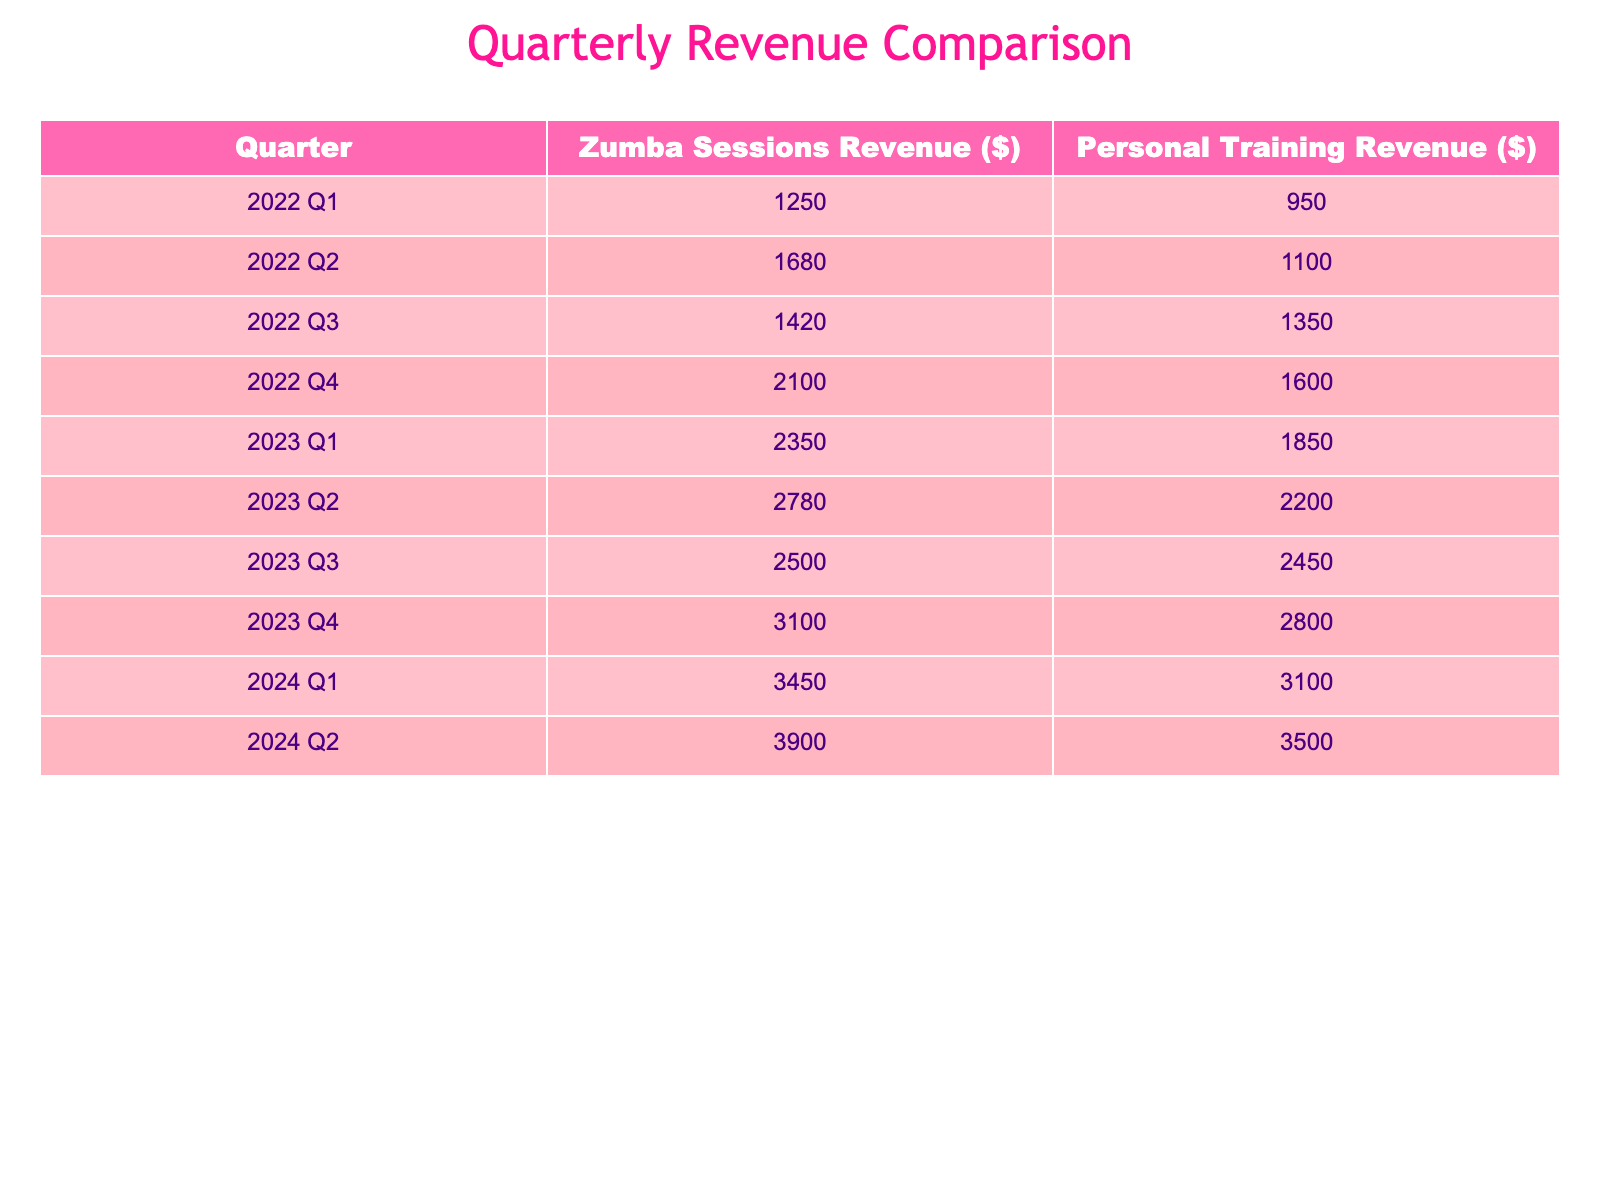What was the revenue from Zumba sessions in 2023 Q2? The table shows that in 2023 Q2, the revenue from Zumba sessions is listed as $2780.
Answer: $2780 What is the total revenue from personal training over all quarters in 2022? By summing the personal training revenue for each quarter in 2022, we get: 950 + 1100 + 1350 + 1600 = 4000.
Answer: $4000 Was the Zumba revenue in 2024 Q1 higher than in 2022 Q4? In 2024 Q1, the Zumba revenue was $3450, and in 2022 Q4, it was $2100. Since $3450 is greater than $2100, the statement is true.
Answer: Yes Calculate the average Zumba revenue for the first two quarters of 2023. For the first two quarters of 2023, the revenues are: 2350 (Q1) and 2780 (Q2). The sum is 2350 + 2780 = 5130. The average is then 5130 / 2 = 2565.
Answer: $2565 Which quarter had the highest revenue from personal training in 2023? Looking at the personal training revenue in 2023, the values are: 1850 (Q1), 2200 (Q2), 2450 (Q3), and 2800 (Q4). The highest is 2800 in Q4.
Answer: 2023 Q4 By how much did the Zumba revenue increase from 2022 Q1 to 2024 Q2? The Zumba revenue in 2022 Q1 is $1250 and in 2024 Q2 it is $3900. To find the increase, calculate: 3900 - 1250 = 2650.
Answer: $2650 What was the personal training revenue in Q3 2022 in comparison to Q3 2023? In Q3 2022, the personal training revenue was $1350, while in Q3 2023, it was $2450. Since $2450 is higher than $1350, the revenue increased.
Answer: Increased Find the total revenue from Zumba sessions for the first half of 2024. The revenues for Zumba in the first half of 2024 are: 3450 (Q1) and 3900 (Q2). Their total is 3450 + 3900 = 7350.
Answer: $7350 Is the Zumba revenue in 2023 Q1 less than $2400? The Zumba revenue in 2023 Q1 is $2350. Since $2350 is less than $2400, the statement is true.
Answer: Yes What was the difference in revenue between Zumba sessions and personal training in 2023 Q3? The Zumba revenue in Q3 2023 is $2500 and personal training is $2450. The difference is: 2500 - 2450 = 50.
Answer: $50 